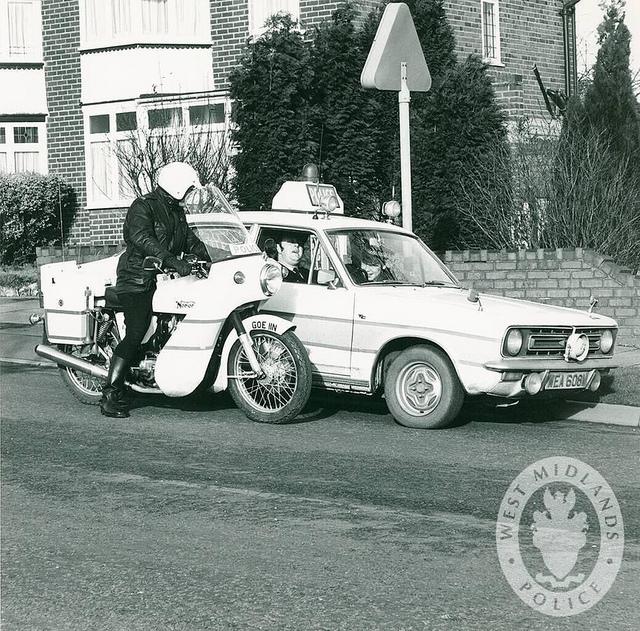How many helmets do you see?
Concise answer only. 1. What police department is this?
Give a very brief answer. West midlands. Is the cop pulling someone over?
Quick response, please. Yes. What kind of vehicle is shown?
Concise answer only. Car and motorcycle. Is this black and white?
Keep it brief. Yes. 